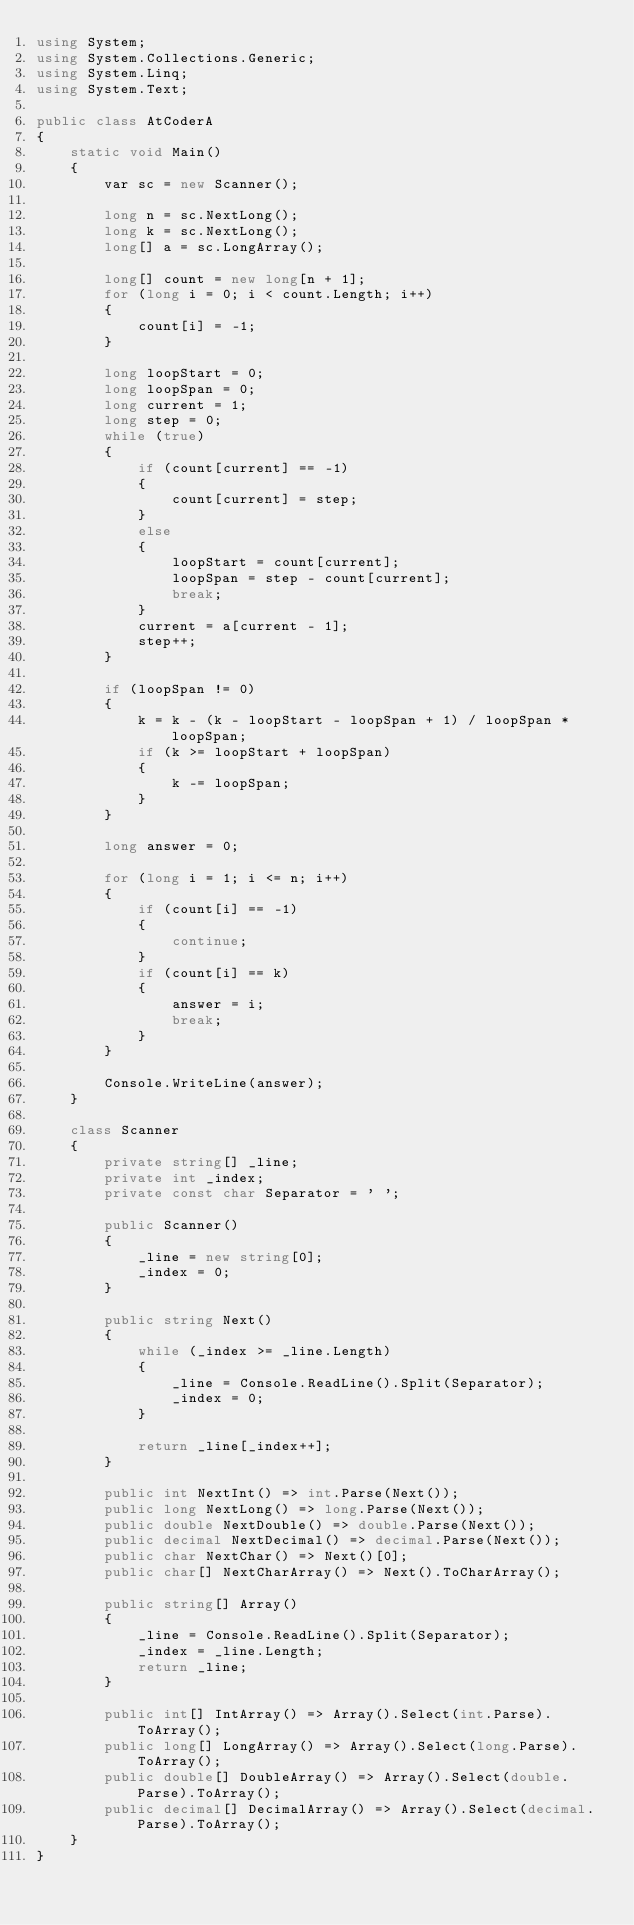Convert code to text. <code><loc_0><loc_0><loc_500><loc_500><_C#_>using System;
using System.Collections.Generic;
using System.Linq;
using System.Text;

public class AtCoderA
{
    static void Main()
    {
        var sc = new Scanner();

        long n = sc.NextLong();
        long k = sc.NextLong();
        long[] a = sc.LongArray();

        long[] count = new long[n + 1];
        for (long i = 0; i < count.Length; i++)
        {
            count[i] = -1;
        }

        long loopStart = 0;
        long loopSpan = 0;
        long current = 1;
        long step = 0;
        while (true)
        {
            if (count[current] == -1)
            {
                count[current] = step;
            }
            else
            {
                loopStart = count[current];
                loopSpan = step - count[current];
                break;
            }
            current = a[current - 1];
            step++;
        }

        if (loopSpan != 0)
        {
            k = k - (k - loopStart - loopSpan + 1) / loopSpan * loopSpan;
            if (k >= loopStart + loopSpan)
            {
                k -= loopSpan;
            }
        }

        long answer = 0;

        for (long i = 1; i <= n; i++)
        {
            if (count[i] == -1)
            {
                continue;
            }
            if (count[i] == k)
            {
                answer = i;
                break;
            }
        }

        Console.WriteLine(answer);
    }

    class Scanner
    {
        private string[] _line;
        private int _index;
        private const char Separator = ' ';

        public Scanner()
        {
            _line = new string[0];
            _index = 0;
        }

        public string Next()
        {
            while (_index >= _line.Length)
            {
                _line = Console.ReadLine().Split(Separator);
                _index = 0;
            }

            return _line[_index++];
        }

        public int NextInt() => int.Parse(Next());
        public long NextLong() => long.Parse(Next());
        public double NextDouble() => double.Parse(Next());
        public decimal NextDecimal() => decimal.Parse(Next());
        public char NextChar() => Next()[0];
        public char[] NextCharArray() => Next().ToCharArray();

        public string[] Array()
        {
            _line = Console.ReadLine().Split(Separator);
            _index = _line.Length;
            return _line;
        }

        public int[] IntArray() => Array().Select(int.Parse).ToArray();
        public long[] LongArray() => Array().Select(long.Parse).ToArray();
        public double[] DoubleArray() => Array().Select(double.Parse).ToArray();
        public decimal[] DecimalArray() => Array().Select(decimal.Parse).ToArray();
    }
}</code> 